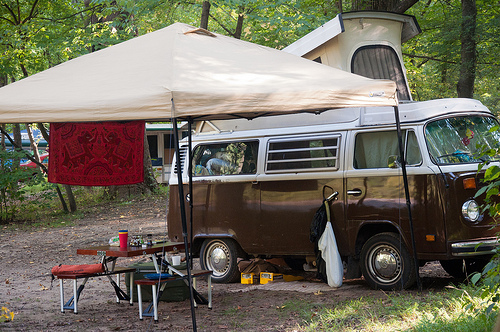<image>
Is the van to the left of the table? No. The van is not to the left of the table. From this viewpoint, they have a different horizontal relationship. 